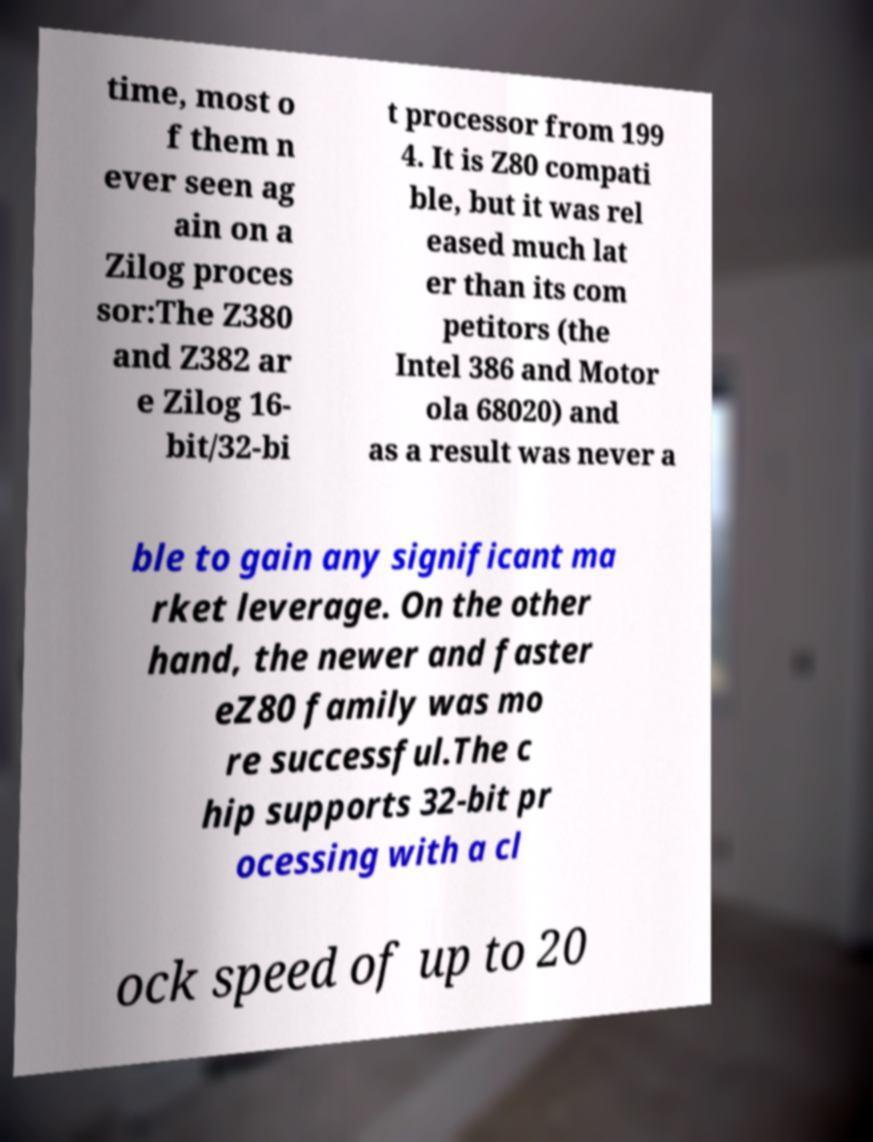Can you read and provide the text displayed in the image?This photo seems to have some interesting text. Can you extract and type it out for me? time, most o f them n ever seen ag ain on a Zilog proces sor:The Z380 and Z382 ar e Zilog 16- bit/32-bi t processor from 199 4. It is Z80 compati ble, but it was rel eased much lat er than its com petitors (the Intel 386 and Motor ola 68020) and as a result was never a ble to gain any significant ma rket leverage. On the other hand, the newer and faster eZ80 family was mo re successful.The c hip supports 32-bit pr ocessing with a cl ock speed of up to 20 